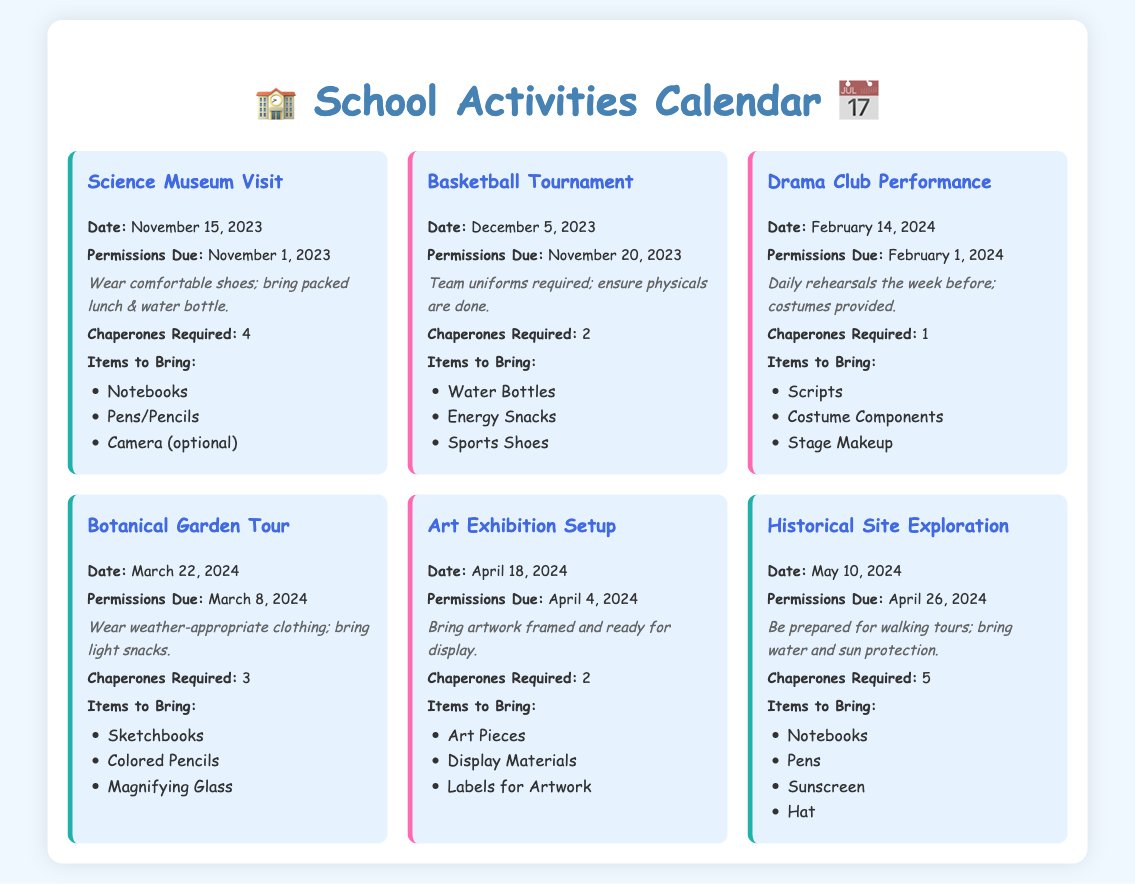what is the date of the Science Museum Visit? The date listed for the Science Museum Visit is found in the event details.
Answer: November 15, 2023 how many chaperones are required for the Botanical Garden Tour? The requirement for chaperones is specified in the event details of the Botanical Garden Tour.
Answer: 3 when is the permission due for the Basketball Tournament? The due date for permissions is mentioned in the details for the Basketball Tournament event.
Answer: November 20, 2023 what items should be brought for the Art Exhibition Setup? The items to bring for the Art Exhibition Setup are listed under the relevant event section.
Answer: Art Pieces, Display Materials, Labels for Artwork how many total events are listed in the calendar? The total number of events can be calculated by counting all the event sections in the calendar.
Answer: 6 which event requires the most chaperones? The number of chaperones required for each event can be compared to determine which requires the most.
Answer: Historical Site Exploration what is the earliest permission due date? The earliest permission due date is determined by comparing all the due dates listed for the events.
Answer: November 1, 2023 what should students wear for the Drama Club Performance? The note related to the Drama Club Performance indicates specific attire requirements.
Answer: Costumes provided how many total field trips are on the calendar? The field trips are identified by their category in the event list, and the total can be counted.
Answer: 3 